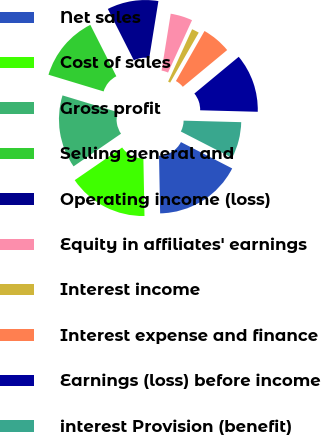Convert chart to OTSL. <chart><loc_0><loc_0><loc_500><loc_500><pie_chart><fcel>Net sales<fcel>Cost of sales<fcel>Gross profit<fcel>Selling general and<fcel>Operating income (loss)<fcel>Equity in affiliates' earnings<fcel>Interest income<fcel>Interest expense and finance<fcel>Earnings (loss) before income<fcel>interest Provision (benefit)<nl><fcel>17.14%<fcel>15.71%<fcel>14.28%<fcel>12.86%<fcel>10.0%<fcel>4.29%<fcel>1.43%<fcel>5.72%<fcel>11.43%<fcel>7.14%<nl></chart> 